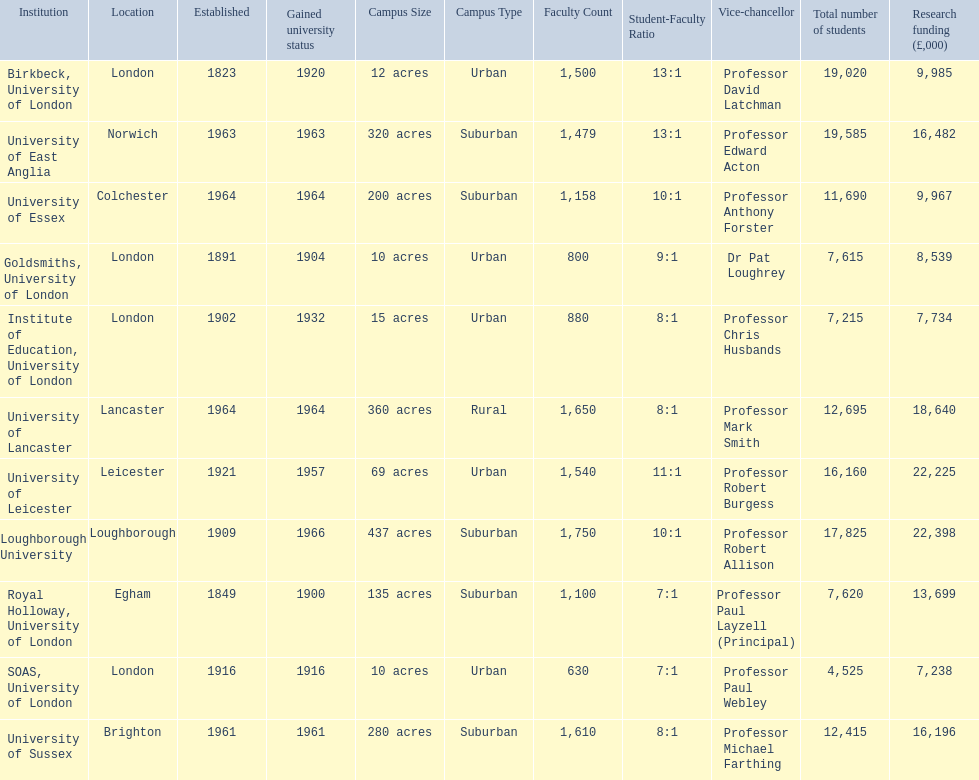What are the names of all the institutions? Birkbeck, University of London, University of East Anglia, University of Essex, Goldsmiths, University of London, Institute of Education, University of London, University of Lancaster, University of Leicester, Loughborough University, Royal Holloway, University of London, SOAS, University of London, University of Sussex. In what range of years were these institutions established? 1823, 1963, 1964, 1891, 1902, 1964, 1921, 1909, 1849, 1916, 1961. In what range of years did these institutions gain university status? 1920, 1963, 1964, 1904, 1932, 1964, 1957, 1966, 1900, 1916, 1961. What institution most recently gained university status? Loughborough University. 